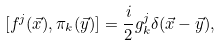<formula> <loc_0><loc_0><loc_500><loc_500>[ f ^ { j } ( \vec { x } ) , \pi _ { k } ( \vec { y } ) ] = \frac { i } { 2 } g _ { k } ^ { j } \delta ( \vec { x } - \vec { y } ) ,</formula> 